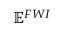<formula> <loc_0><loc_0><loc_500><loc_500>\mathbb { E } ^ { F W I }</formula> 